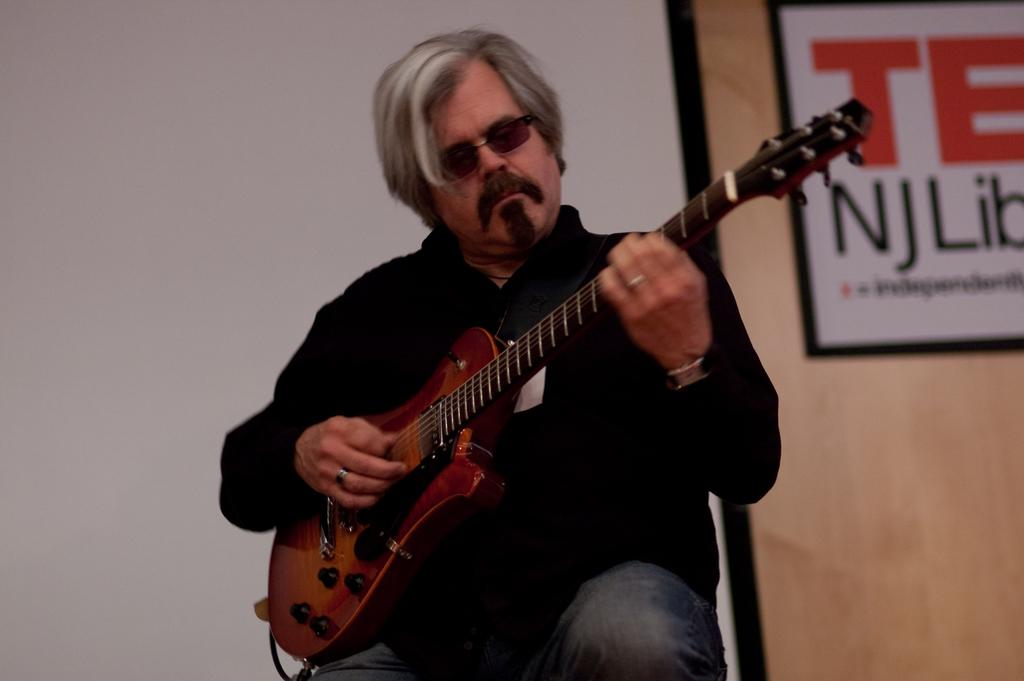What is the person in the image doing? The person in the image is playing a guitar. What accessories is the person wearing? The person is wearing sunglasses, a ring, and a watch. What type of clothing is the person wearing? The person is wearing clothes. What is visible behind the person in the image? There is a screen behind the person. Can you tell me how many donkeys are present in the image? There are no donkeys present in the image; it features a person playing a guitar. What type of wire is being used to connect the guitar to the screen? There is no wire visible in the image; the guitar and screen are not connected in any way. 